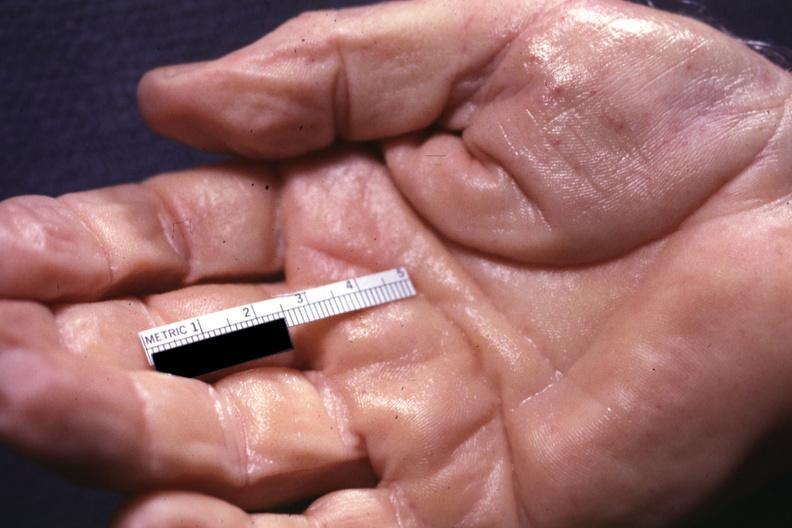what shows well shown simian crease?
Answer the question using a single word or phrase. No 